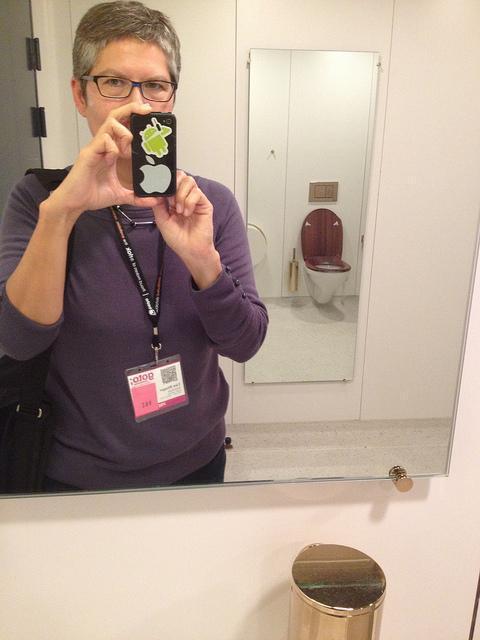How many mirrors can be seen?
Give a very brief answer. 2. 